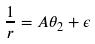<formula> <loc_0><loc_0><loc_500><loc_500>\frac { 1 } { r } = A \theta _ { 2 } + \epsilon</formula> 